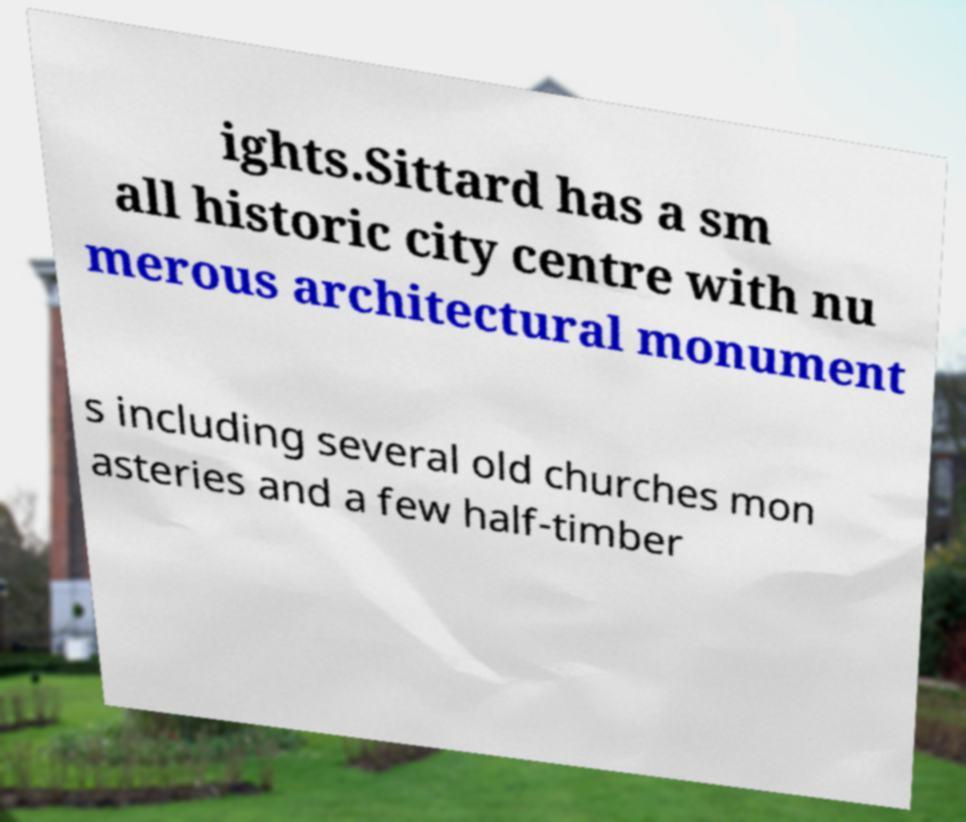Could you extract and type out the text from this image? ights.Sittard has a sm all historic city centre with nu merous architectural monument s including several old churches mon asteries and a few half-timber 